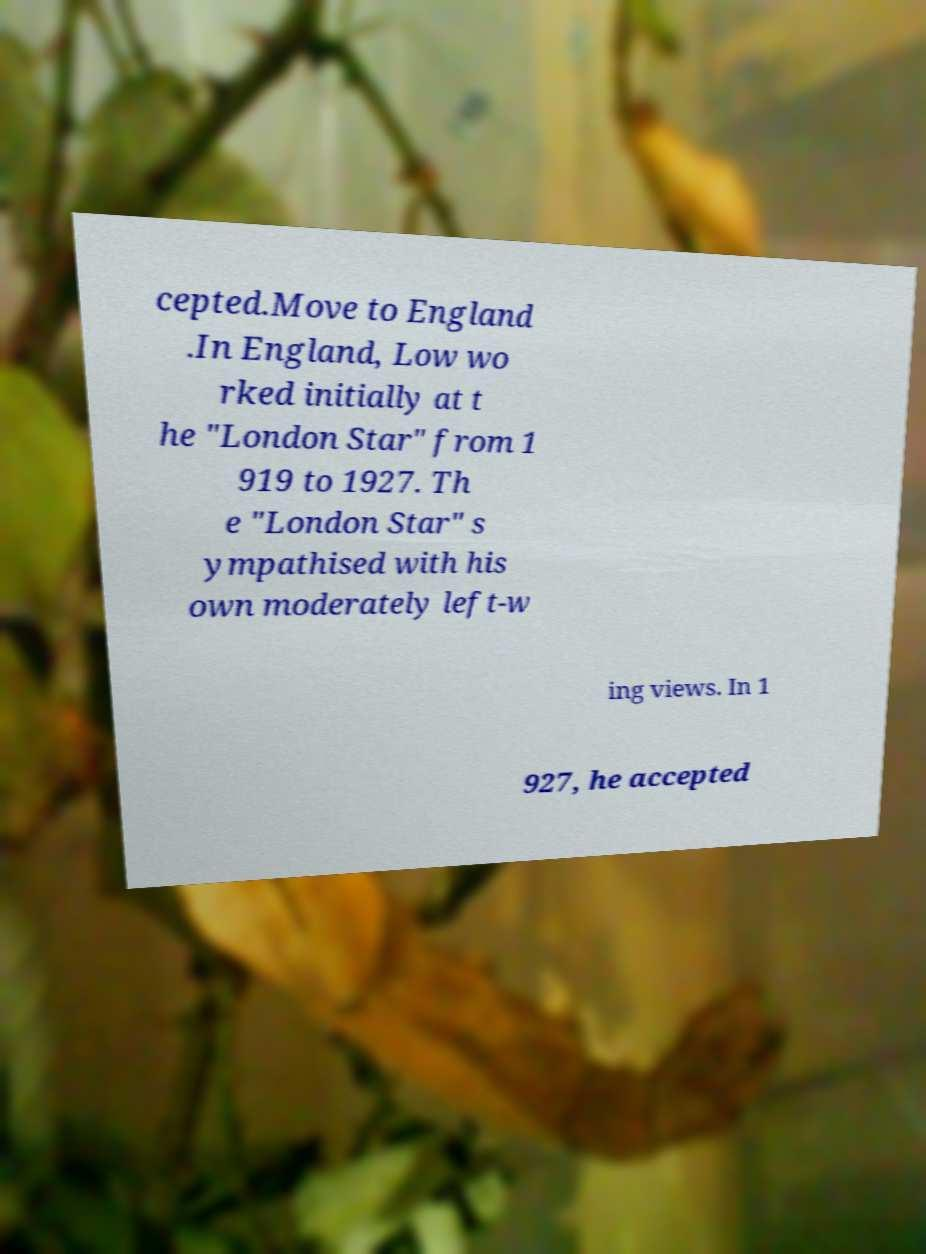Can you accurately transcribe the text from the provided image for me? cepted.Move to England .In England, Low wo rked initially at t he "London Star" from 1 919 to 1927. Th e "London Star" s ympathised with his own moderately left-w ing views. In 1 927, he accepted 